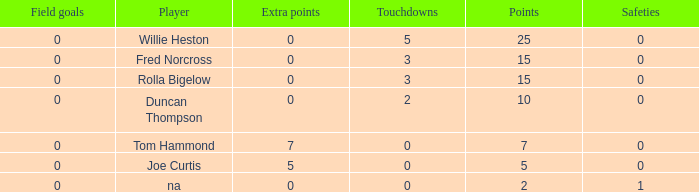How many Touchdowns have a Player of rolla bigelow, and an Extra points smaller than 0? None. 